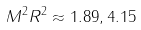Convert formula to latex. <formula><loc_0><loc_0><loc_500><loc_500>M ^ { 2 } R ^ { 2 } \approx 1 . 8 9 , 4 . 1 5</formula> 